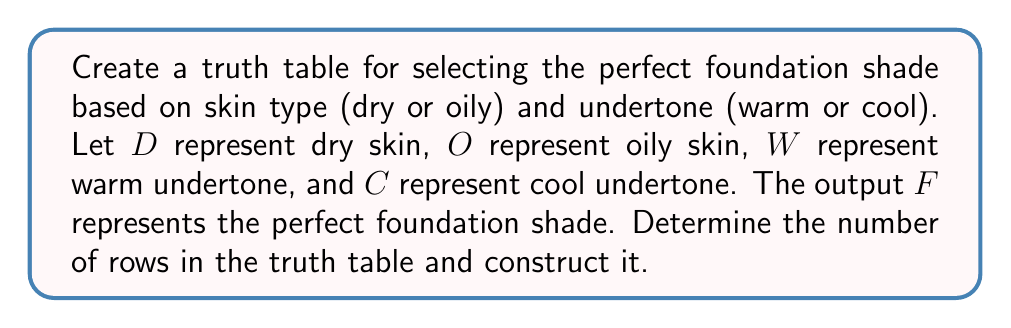Can you answer this question? To create a truth table for this scenario, we need to follow these steps:

1. Identify the number of input variables:
   We have two binary variables: skin type (dry or oily) and undertone (warm or cool).

2. Calculate the number of rows in the truth table:
   Number of rows = $2^n$, where $n$ is the number of input variables
   In this case, $n = 2$, so the number of rows = $2^2 = 4$

3. Construct the truth table:
   - List all possible combinations of input variables
   - Assign output values based on the given conditions

Here's the truth table:

$$
\begin{array}{|c|c|c|c|}
\hline
D & O & W & C & F \\
\hline
0 & 1 & 0 & 1 & 1 \\
0 & 1 & 1 & 0 & 2 \\
1 & 0 & 0 & 1 & 3 \\
1 & 0 & 1 & 0 & 4 \\
\hline
\end{array}
$$

Where:
- $F = 1$ represents a foundation shade for oily skin with cool undertone
- $F = 2$ represents a foundation shade for oily skin with warm undertone
- $F = 3$ represents a foundation shade for dry skin with cool undertone
- $F = 4$ represents a foundation shade for dry skin with warm undertone

Note that $D$ and $O$ are mutually exclusive (only one can be true at a time), as are $W$ and $C$.
Answer: 4 rows; Truth table with 4 input columns (D, O, W, C) and 1 output column (F) 